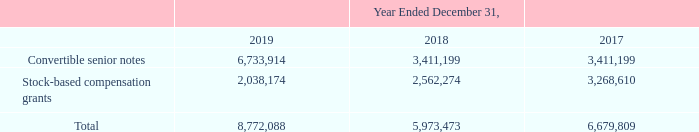(12) Basic and Diluted Net Loss per Share
Basic net loss per common share is computed by dividing net loss by the weighted-average number of shares of common stock outstanding during the period. Diluted net loss per share is computed by giving effect to all potential dilutive shares of common stock. Basic and diluted net loss per share of common stock were the same for all periods presented as the impact of all potentially dilutive securities outstanding was anti-dilutive. The Company uses the if converted method for calculating any potential dilutive effect on diluted loss per share.
The following common equivalent shares were excluded from the diluted net loss per share calculation because their inclusion would have been anti-dilutive:
In connection with the issuance of the 2024 Notes in December 2019, the Company paid $44.9 million to enter into capped call option agreements to reduce the potential dilution to holders of the Company’s common stock upon conversion of the 2024 Notes. In connection with the issuance of the 2022 Notes in November 2017, the Company paid $12.9 million to enter into capped call option agreements to reduce the potential dilution to holders of the Company’s common stock upon conversion of the 2022 Notes.
In December 2019, the Company partially terminated capped call options related to the 2022 Notes and received $5.8 million. The capped call option agreements are excluded from the calculation of diluted net loss per share attributable to common stockholders as their effect is antidilutive.
How is basic net loss per common share computed? By dividing net loss by the weighted-average number of shares of common stock outstanding during the period. What is the average Convertible senior notes for the period December 31, 2019 to December 31, 2018? (6,733,914+3,411,199) / 2
Answer: 5072556.5. What is the average Stock-based compensation grants for the period December 31, 2019 to December 31, 2018? (2,038,174+2,562,274) / 2
Answer: 2300224. In which year was Convertible senior notes less than 4,000,000? Locate and analyze convertible senior notes in row 3
answer: 2018, 2017. What was Stock-based compensation grants in 2019, 2018 and 2017 respectively? 2,038,174, 2,562,274, 3,268,610. What was the amount paid by the company to enter into capped call option agreements to reduce the potential dilution? $44.9 million. 